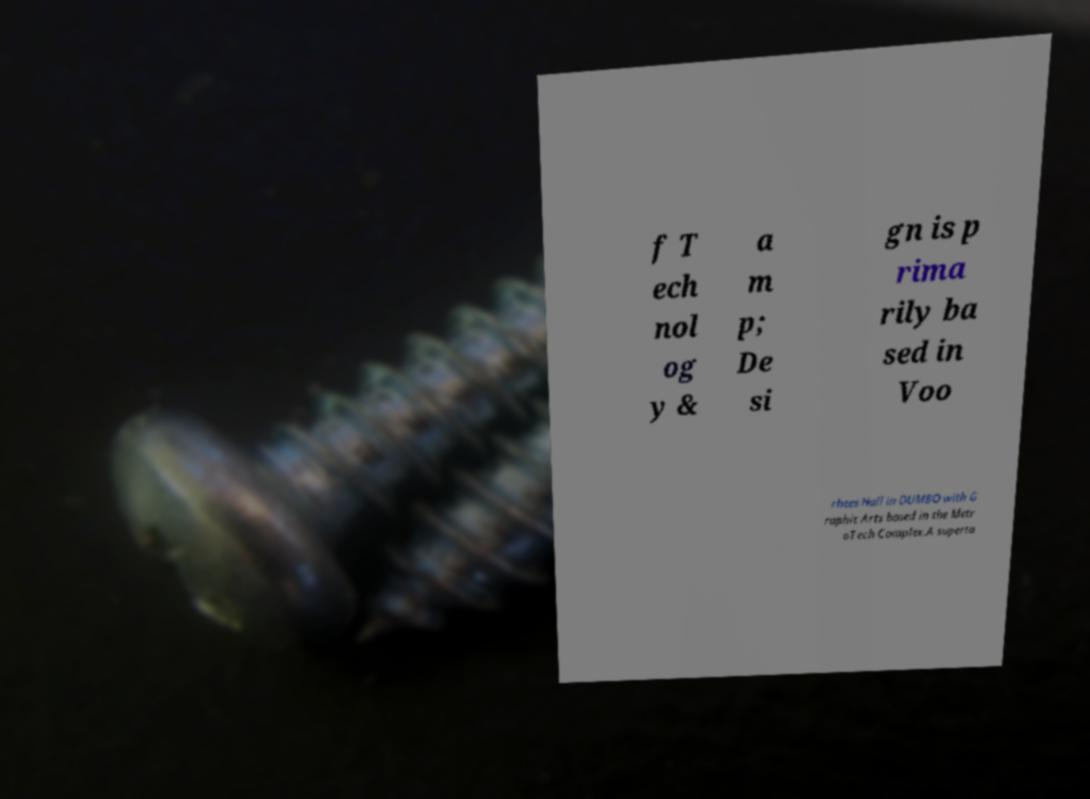Can you accurately transcribe the text from the provided image for me? f T ech nol og y & a m p; De si gn is p rima rily ba sed in Voo rhees Hall in DUMBO with G raphic Arts based in the Metr oTech Complex.A superta 